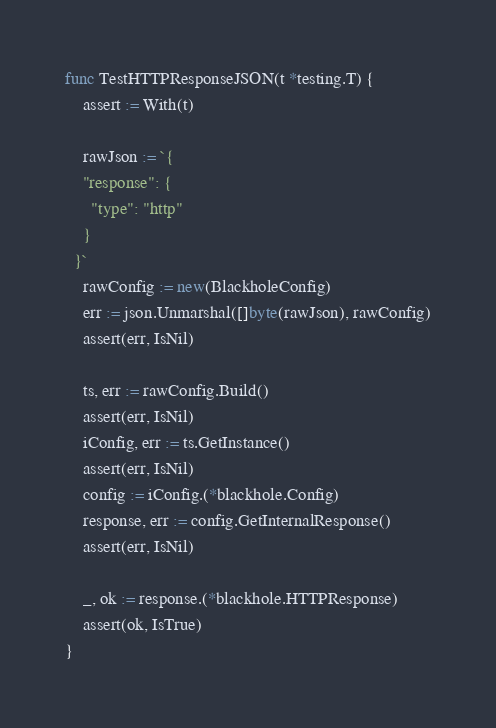<code> <loc_0><loc_0><loc_500><loc_500><_Go_>
func TestHTTPResponseJSON(t *testing.T) {
	assert := With(t)

	rawJson := `{
    "response": {
      "type": "http"
    }
  }`
	rawConfig := new(BlackholeConfig)
	err := json.Unmarshal([]byte(rawJson), rawConfig)
	assert(err, IsNil)

	ts, err := rawConfig.Build()
	assert(err, IsNil)
	iConfig, err := ts.GetInstance()
	assert(err, IsNil)
	config := iConfig.(*blackhole.Config)
	response, err := config.GetInternalResponse()
	assert(err, IsNil)

	_, ok := response.(*blackhole.HTTPResponse)
	assert(ok, IsTrue)
}
</code> 